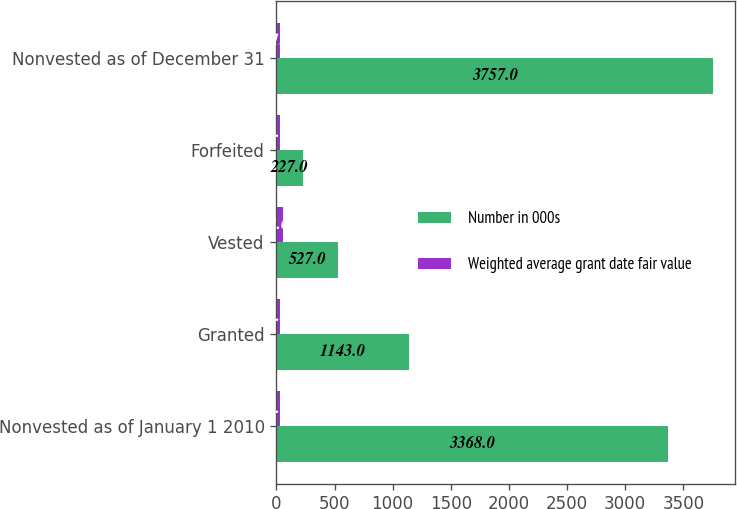Convert chart to OTSL. <chart><loc_0><loc_0><loc_500><loc_500><stacked_bar_chart><ecel><fcel>Nonvested as of January 1 2010<fcel>Granted<fcel>Vested<fcel>Forfeited<fcel>Nonvested as of December 31<nl><fcel>Number in 000s<fcel>3368<fcel>1143<fcel>527<fcel>227<fcel>3757<nl><fcel>Weighted average grant date fair value<fcel>34.83<fcel>31.32<fcel>52.65<fcel>30.66<fcel>31.5<nl></chart> 